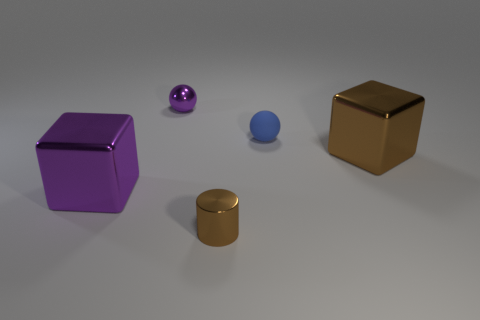Add 3 red matte cubes. How many objects exist? 8 Subtract all cylinders. How many objects are left? 4 Add 1 big things. How many big things exist? 3 Subtract 0 green blocks. How many objects are left? 5 Subtract all purple cylinders. Subtract all blue spheres. How many objects are left? 4 Add 1 small blue things. How many small blue things are left? 2 